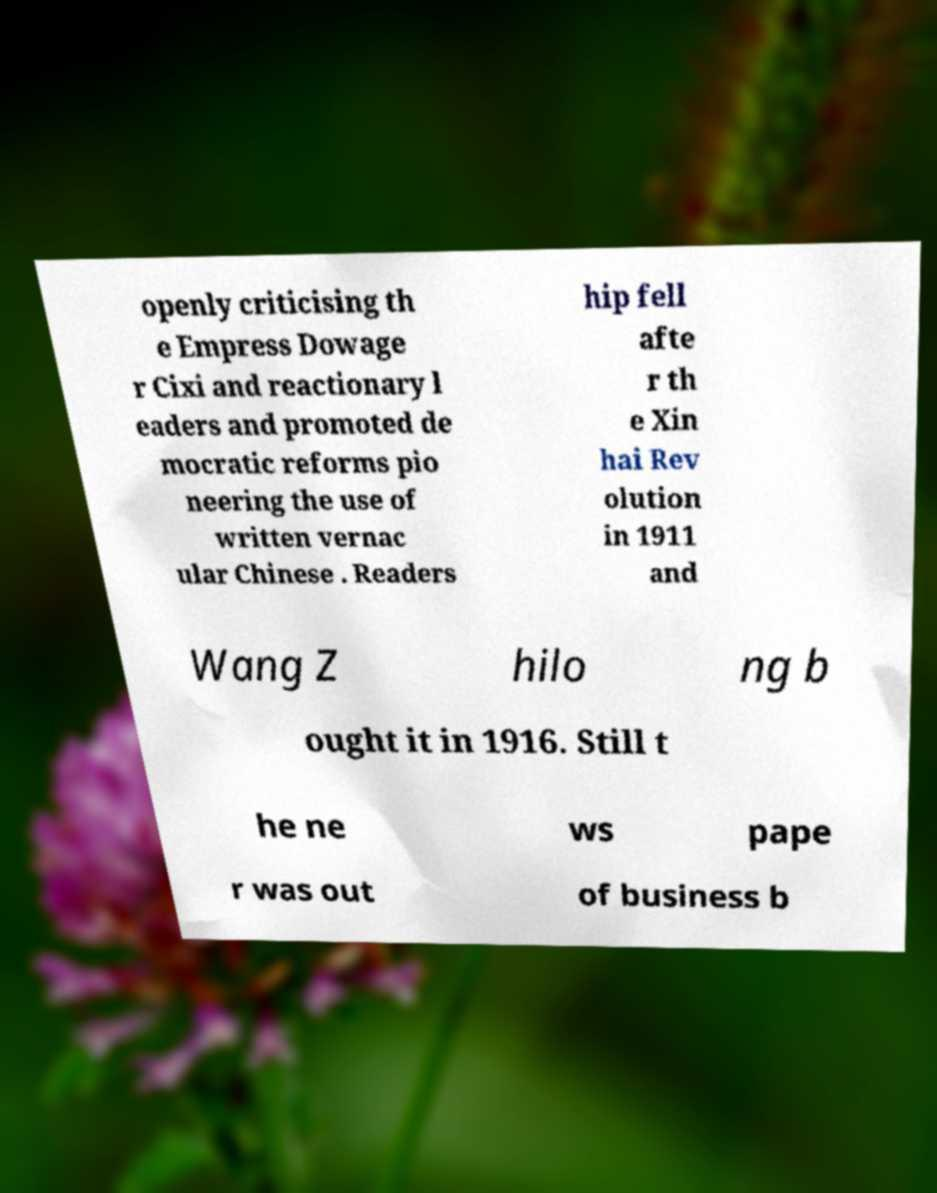Can you accurately transcribe the text from the provided image for me? openly criticising th e Empress Dowage r Cixi and reactionary l eaders and promoted de mocratic reforms pio neering the use of written vernac ular Chinese . Readers hip fell afte r th e Xin hai Rev olution in 1911 and Wang Z hilo ng b ought it in 1916. Still t he ne ws pape r was out of business b 